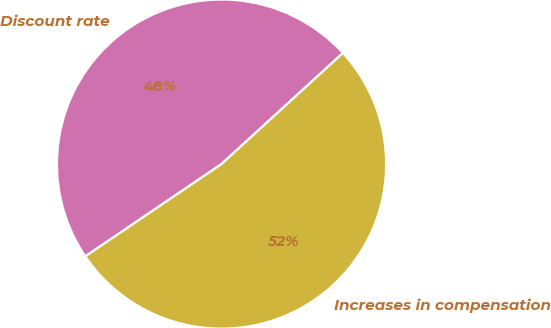<chart> <loc_0><loc_0><loc_500><loc_500><pie_chart><fcel>Discount rate<fcel>Increases in compensation<nl><fcel>47.69%<fcel>52.31%<nl></chart> 